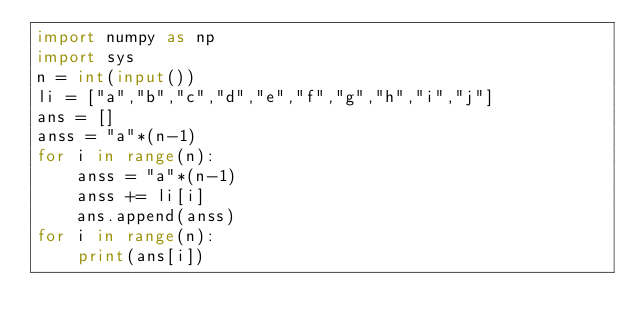Convert code to text. <code><loc_0><loc_0><loc_500><loc_500><_Python_>import numpy as np
import sys
n = int(input())
li = ["a","b","c","d","e","f","g","h","i","j"]
ans = []
anss = "a"*(n-1)
for i in range(n):
    anss = "a"*(n-1)
    anss += li[i]
    ans.append(anss)
for i in range(n):
    print(ans[i])</code> 